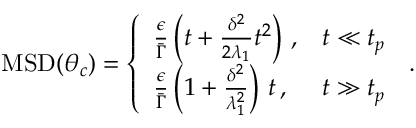<formula> <loc_0><loc_0><loc_500><loc_500>\begin{array} { r } { M S D ( \theta _ { c } ) = \left \{ \begin{array} { l l } { \frac { \epsilon } { \bar { \Gamma } } \left ( t + \frac { \delta ^ { 2 } } { 2 \lambda _ { 1 } } t ^ { 2 } \right ) \, , } & { t \ll t _ { p } } \\ { \frac { \epsilon } { \bar { \Gamma } } \left ( 1 + \frac { \delta ^ { 2 } } { \lambda _ { 1 } ^ { 2 } } \right ) \, t \, , } & { t \gg t _ { p } \, } \end{array} . } \end{array}</formula> 